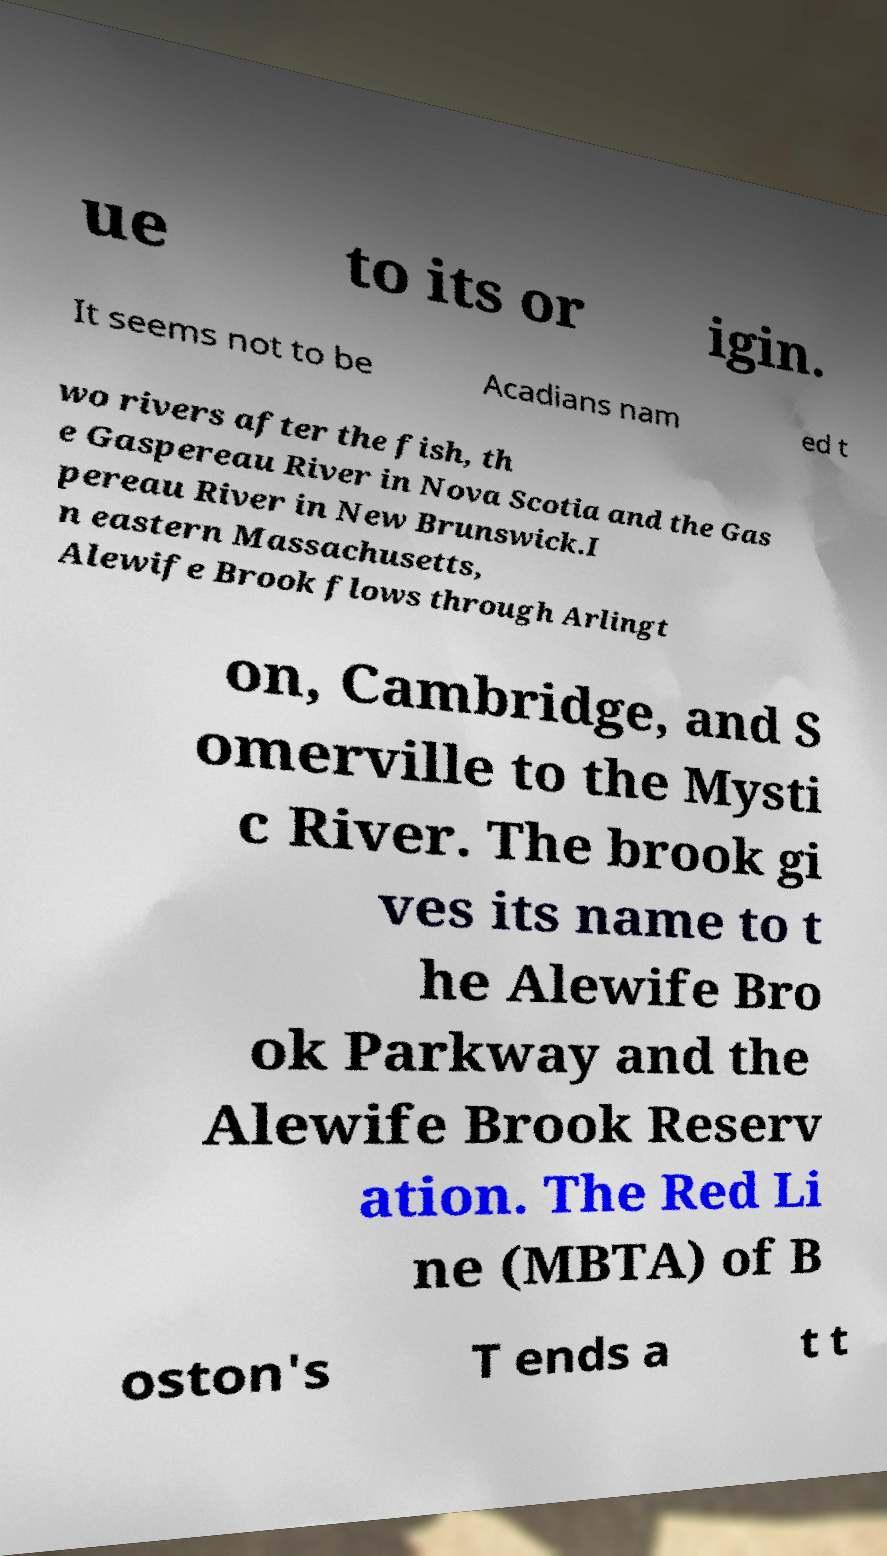What messages or text are displayed in this image? I need them in a readable, typed format. ue to its or igin. It seems not to be Acadians nam ed t wo rivers after the fish, th e Gaspereau River in Nova Scotia and the Gas pereau River in New Brunswick.I n eastern Massachusetts, Alewife Brook flows through Arlingt on, Cambridge, and S omerville to the Mysti c River. The brook gi ves its name to t he Alewife Bro ok Parkway and the Alewife Brook Reserv ation. The Red Li ne (MBTA) of B oston's T ends a t t 